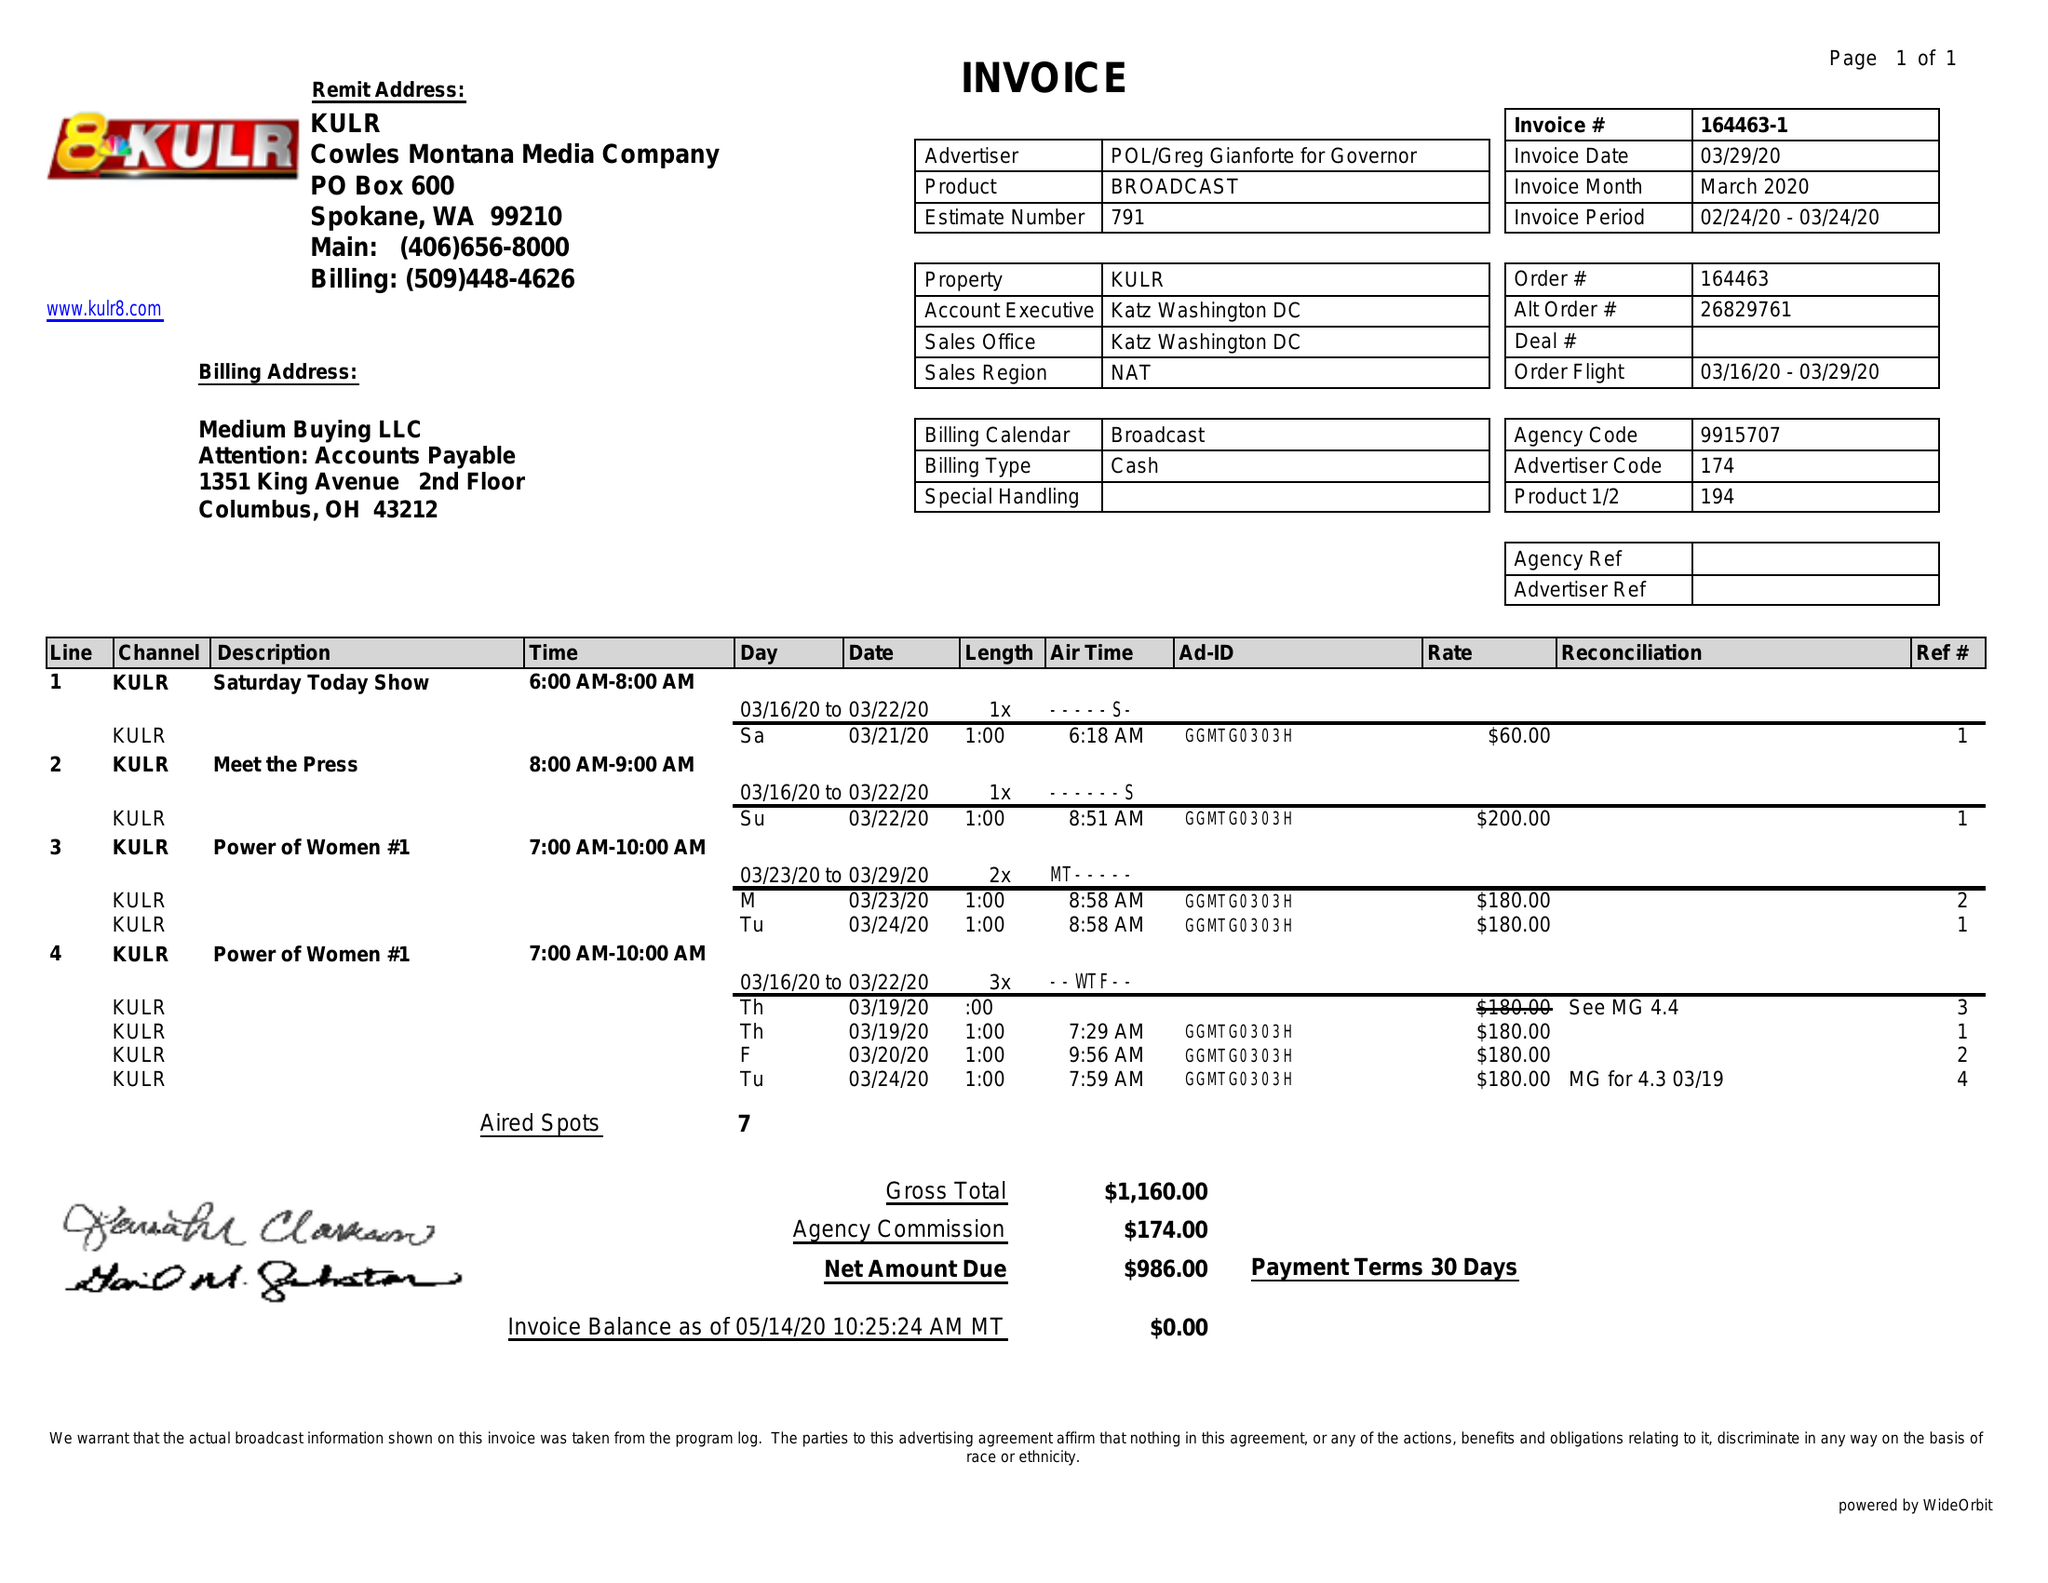What is the value for the contract_num?
Answer the question using a single word or phrase. 164463 